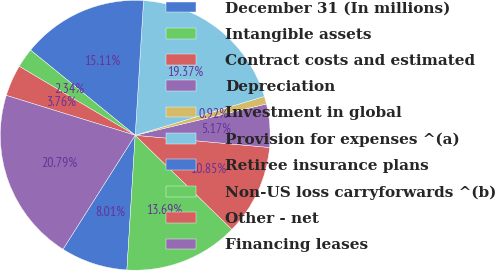Convert chart to OTSL. <chart><loc_0><loc_0><loc_500><loc_500><pie_chart><fcel>December 31 (In millions)<fcel>Intangible assets<fcel>Contract costs and estimated<fcel>Depreciation<fcel>Investment in global<fcel>Provision for expenses ^(a)<fcel>Retiree insurance plans<fcel>Non-US loss carryforwards ^(b)<fcel>Other - net<fcel>Financing leases<nl><fcel>8.01%<fcel>13.69%<fcel>10.85%<fcel>5.17%<fcel>0.92%<fcel>19.37%<fcel>15.11%<fcel>2.34%<fcel>3.76%<fcel>20.79%<nl></chart> 